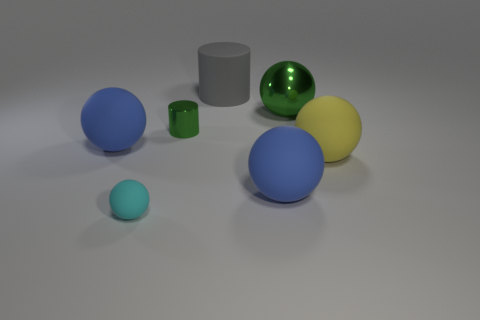Subtract 1 balls. How many balls are left? 4 Subtract all cyan spheres. How many spheres are left? 4 Subtract all green metal balls. How many balls are left? 4 Subtract all yellow spheres. Subtract all gray cylinders. How many spheres are left? 4 Add 2 small gray metal cylinders. How many objects exist? 9 Subtract all balls. How many objects are left? 2 Subtract all purple metal balls. Subtract all rubber balls. How many objects are left? 3 Add 2 big metallic spheres. How many big metallic spheres are left? 3 Add 5 yellow matte things. How many yellow matte things exist? 6 Subtract 1 gray cylinders. How many objects are left? 6 